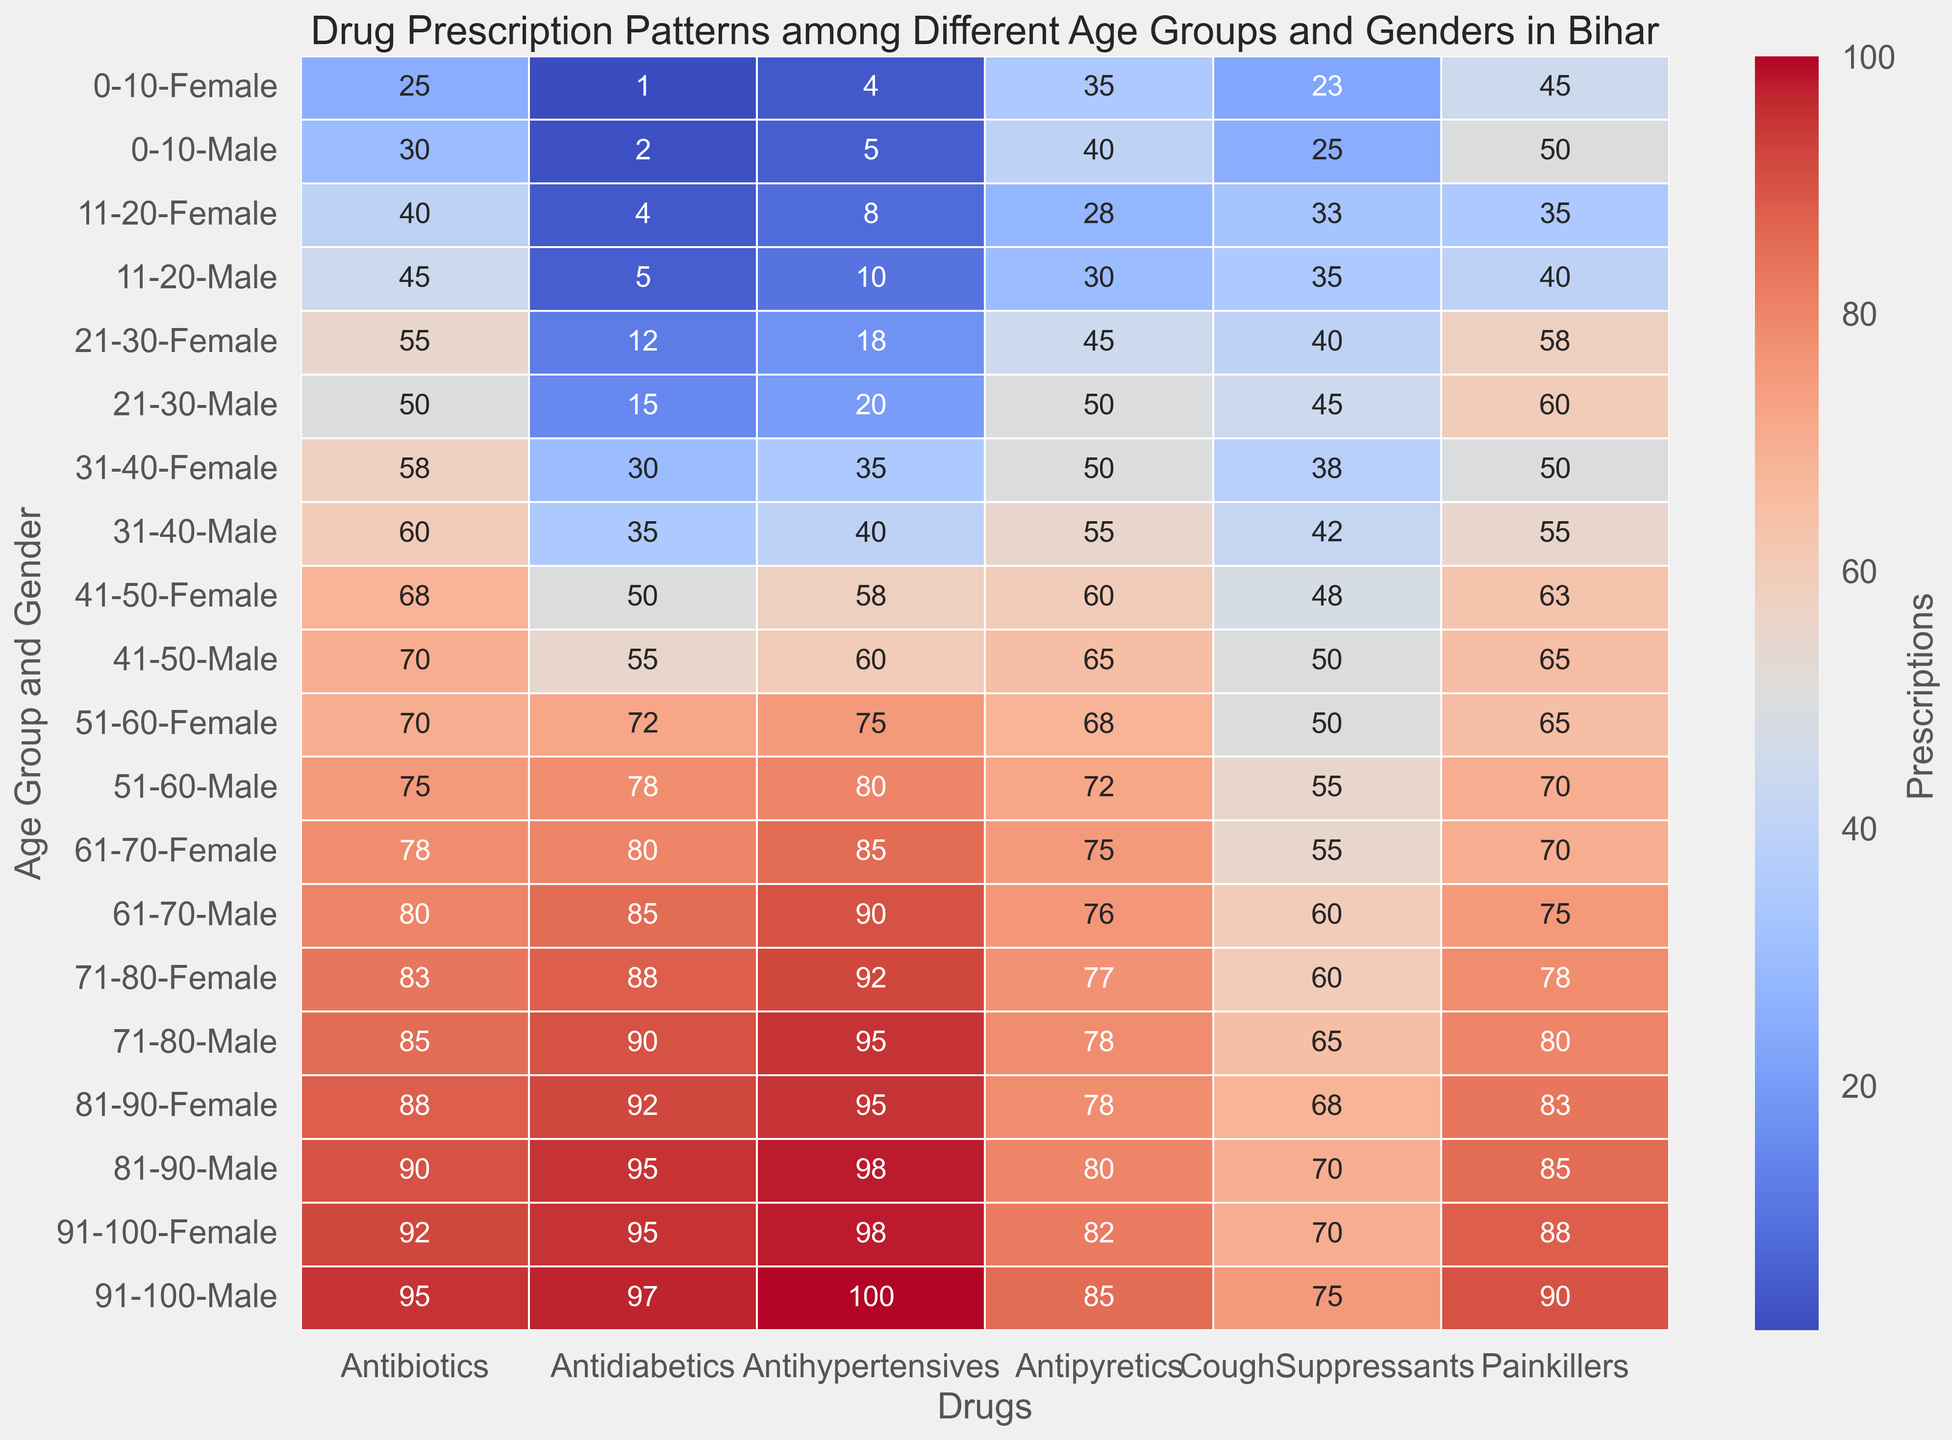Which age group and gender have the highest prescription for Antidiabetics? Look at the cell in the column for Antidiabetics with the highest value and refer to its respective row for Age Group and Gender. The value 97 is highest, which corresponds to the age group 91-100 and Male gender.
Answer: 91-100 Male How many total Painkillers were prescribed to the 41-50 age group for both genders? Look at the 41-50 age group for both Male and Female and sum their Painkillers prescriptions. For Males, it's 65, and for Females, it's 63. So, 65 + 63 = 128.
Answer: 128 Compare the prescriptions of Antibiotics for age group 21-30 between males and females. Which gender has higher values and by how much? Check the values for Antibiotics in age group 21-30; Male has 50, and Female has 55. The difference is 55 - 50 = 5, with Females prescribing more.
Answer: Female, by 5 What is the most prescribed drug for the age group 0-10, male? In the row corresponding to age group 0-10 and Male gender, identify the column with the highest value. The highest value is 50, which corresponds to Painkillers.
Answer: Painkillers Which age group and gender have the highest prescription rate for Antihypertensives across all categories? Find the highest value in the Antihypertensives column and check the respective age group and gender. The highest value is 100, corresponding to the age group 91-100 and Male gender.
Answer: 91-100 Male 